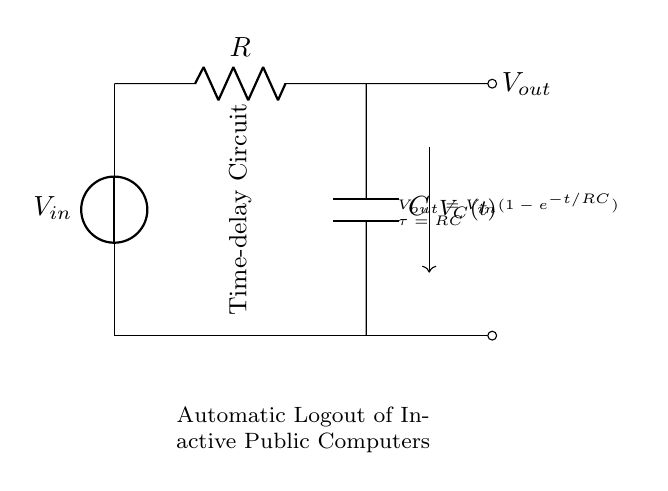What is the input voltage of this circuit? The input voltage is labeled as V sub in on the diagram, which indicates the source voltage that powers the circuit. It is typically connected to the top of the circuit as the supply voltage.
Answer: V in What type of circuit is represented here? The diagram depicts a time-delay circuit, as indicated by the labeling and the configuration of the resistor and capacitor. This type of circuit is designed to allow a delay in the output response based on the RC time constant.
Answer: Time-delay circuit What does the capacitor do in this circuit? The capacitor stores and releases electrical energy in the circuit, influencing the timing of the output voltage. During charging, it helps create a delay, affecting when V out reaches a certain level based on its charge rate.
Answer: Delays output What is the time constant of this circuit? The time constant, denoted by tau, is calculated using the formula tau equals R times C. It represents the time required for the capacitor to charge to about 63.2 percent of V in when connected in this configuration.
Answer: R times C What is the output voltage formula given in the circuit? The output voltage is described by the formula V out equals V in times the quantity of one minus e to the power of negative t divided by R times C. This represents how the output voltage changes over time based on the charging of the capacitor.
Answer: V in times (1 minus e to the power of negative t divided by R times C) What happens to the voltage across the capacitor over time? The voltage across the capacitor gradually increases and follows an exponential charging curve that relies on the RC time constant. As time progresses, the capacitor charges towards V in, influencing V out accordingly.
Answer: Increases exponentially 